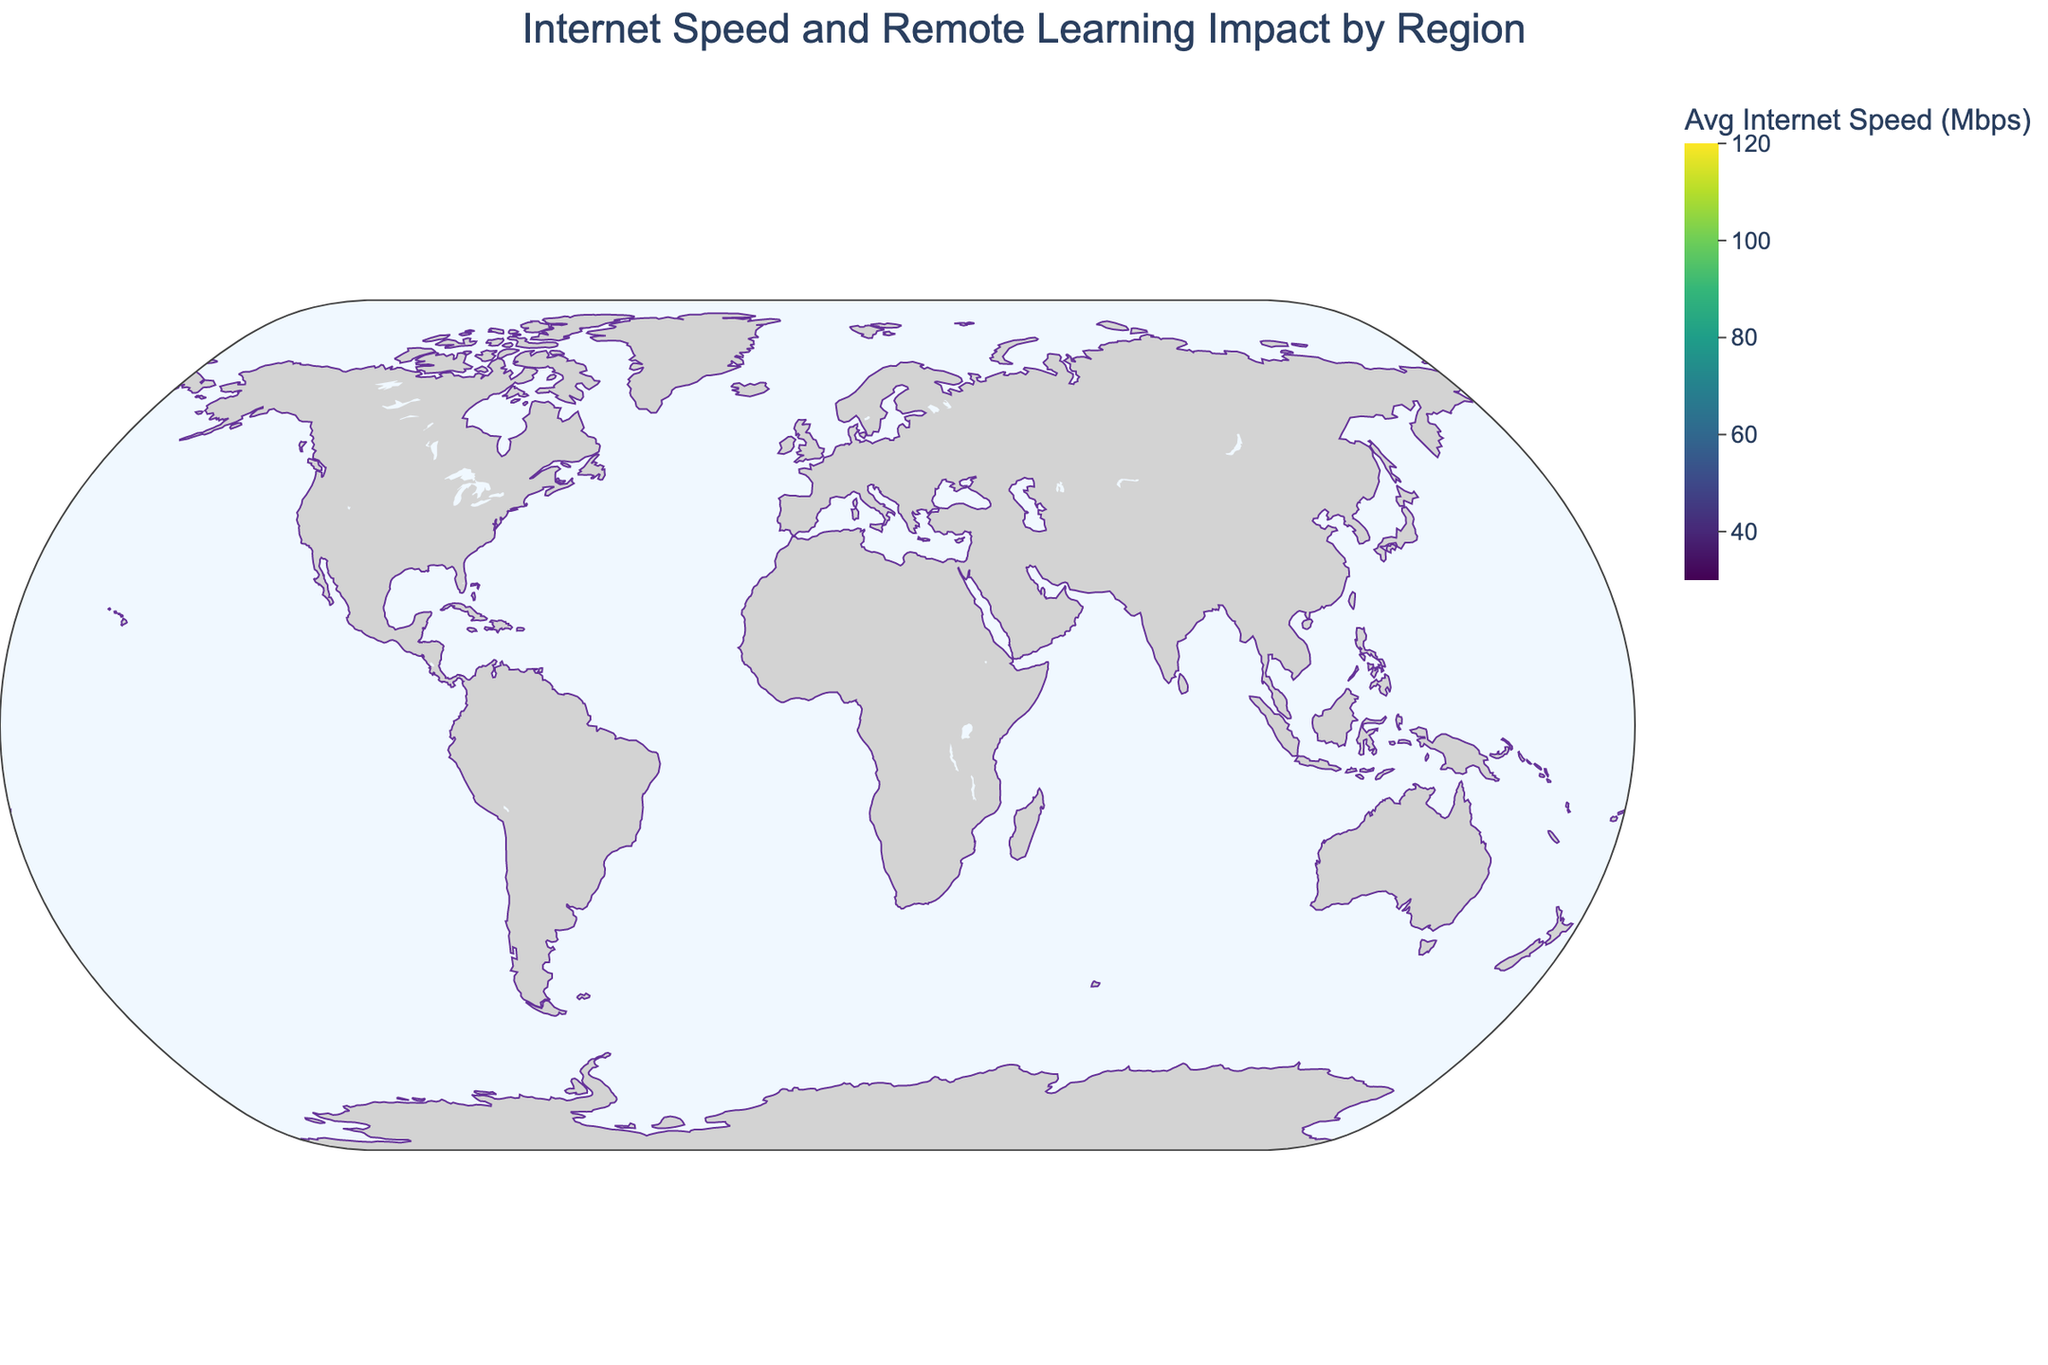What is the title of the plot? The plot's title is displayed at the top of the figure.
Answer: Internet Speed and Remote Learning Impact by Region Which region has the highest average internet speed? By looking at the color intensity and the data points, the region with the highest average internet speed is the darkest color.
Answer: North America What is the remote learning impact score for Africa? The hover information for Africa shows its remote learning impact score.
Answer: 4.5 How many regions have an average internet speed greater than 100 Mbps? Count the regions where the average internet speed is above 100 Mbps.
Answer: 3 Which region has a remote learning impact score equal to 6.0? Check the hover information for each region until you find the region with an impact score of 6.0.
Answer: Southeast Asia What's the difference in remote learning impact scores between North America and Africa? Subtract Africa's impact score from North America's impact score.
Answer: 4.0 Which regions have an average internet speed slower than 50 Mbps? Identify regions with a color indicating below 50 Mbps and verify their speed.
Answer: South Asia, Africa Which region has a better average internet speed, South America or the Middle East? Compare the average internet speeds displayed for South America and the Middle East.
Answer: South America What is the average remote learning impact score for regions with internet speeds above 100 Mbps? Find the regions with internet speeds above 100 Mbps, sum their remote learning impact scores, and divide by the number of such regions: (8.5 + 8.2 + 8.0)/3.
Answer: 8.23 Do regions with higher internet speeds tend to have higher remote learning impact scores? Compare the remote learning impact scores with the internet speeds and observe the trend.
Answer: Yes 